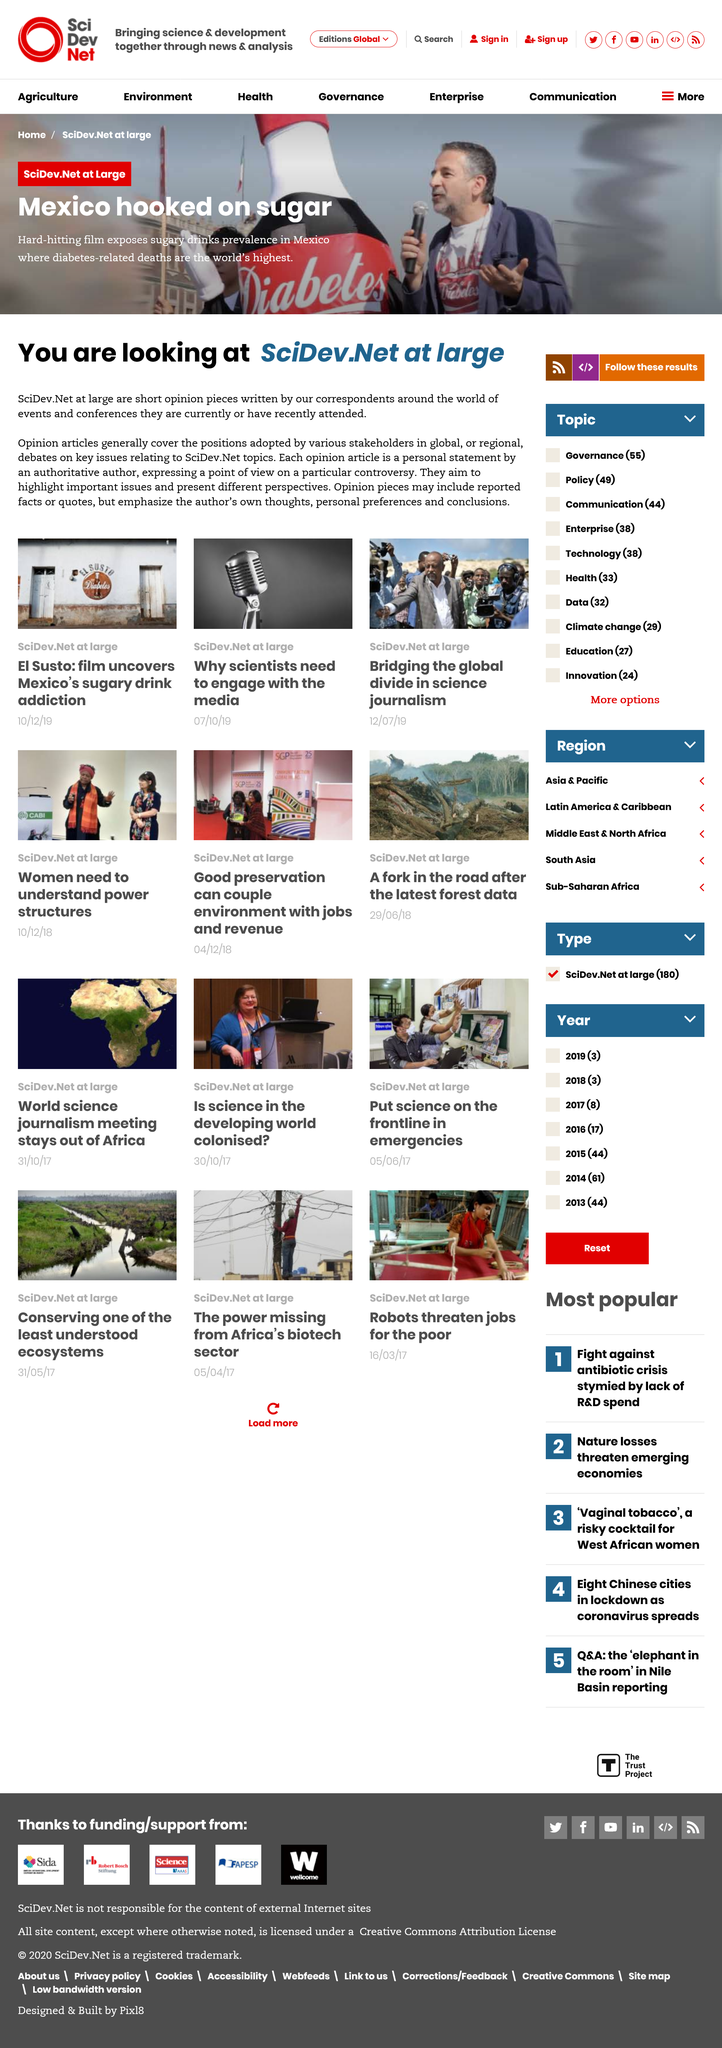Draw attention to some important aspects in this diagram. Mexico is heavily reliant on sugar, indicating a deep addiction to this substance. The prevalence of sugary drinks in Mexico is explored in a hard-hitting film that delivers a powerful message. 